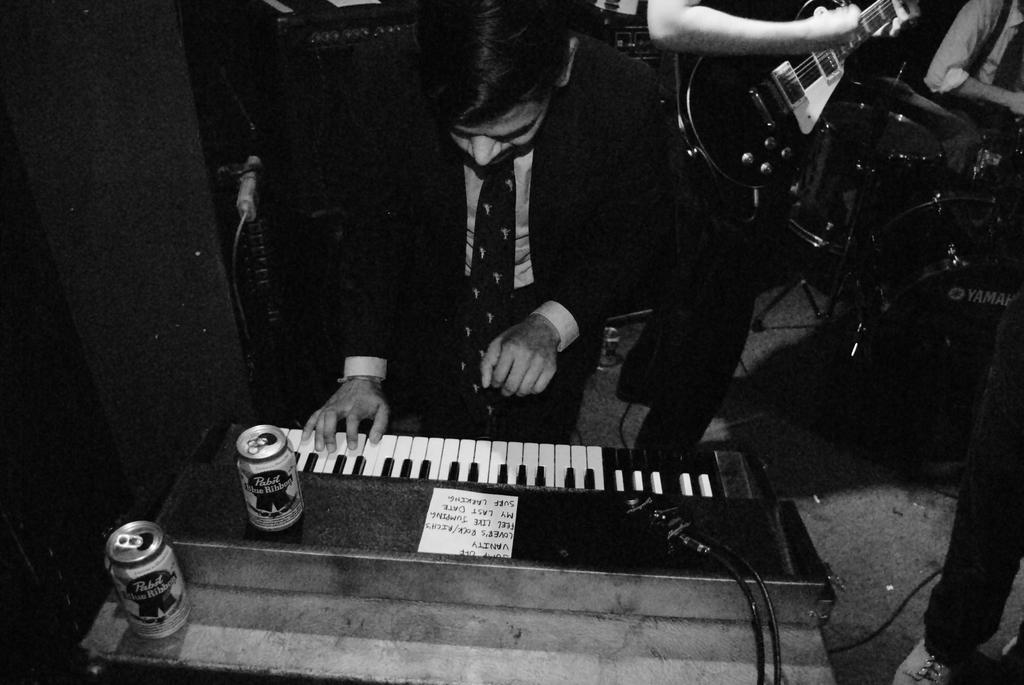How many people are in the image? There are two persons standing in the image. What are the people doing in the image? One person is holding a guitar, and the other person is playing a piano. What objects are on the piano? There are two tins on the piano. What is the position of the person playing the piano? One person is sitting. What other musical instrument can be seen in the image? There is a drum in the image. What type of plate is being used to play the guitar in the image? There is no plate being used to play the guitar in the image; the person is holding a guitar. How many fingers does the person playing the piano have on their left hand in the image? We cannot determine the exact number of fingers the person playing the piano has on their left hand in the image, as the image does not provide that level of detail. 